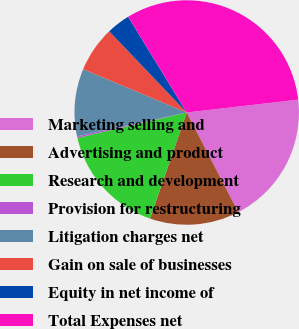Convert chart. <chart><loc_0><loc_0><loc_500><loc_500><pie_chart><fcel>Marketing selling and<fcel>Advertising and product<fcel>Research and development<fcel>Provision for restructuring<fcel>Litigation charges net<fcel>Gain on sale of businesses<fcel>Equity in net income of<fcel>Total Expenses net<nl><fcel>19.23%<fcel>12.9%<fcel>16.06%<fcel>0.22%<fcel>9.73%<fcel>6.56%<fcel>3.39%<fcel>31.91%<nl></chart> 